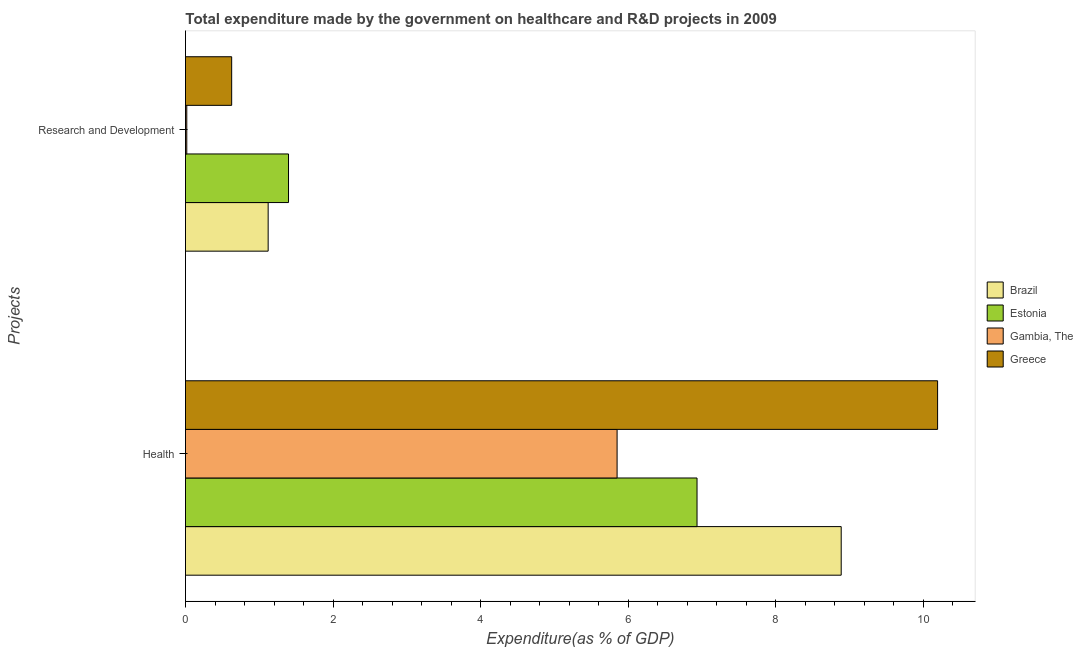How many different coloured bars are there?
Offer a terse response. 4. Are the number of bars per tick equal to the number of legend labels?
Give a very brief answer. Yes. Are the number of bars on each tick of the Y-axis equal?
Your answer should be compact. Yes. How many bars are there on the 2nd tick from the top?
Give a very brief answer. 4. How many bars are there on the 2nd tick from the bottom?
Your answer should be very brief. 4. What is the label of the 2nd group of bars from the top?
Your answer should be compact. Health. What is the expenditure in r&d in Gambia, The?
Provide a short and direct response. 0.02. Across all countries, what is the maximum expenditure in r&d?
Give a very brief answer. 1.4. Across all countries, what is the minimum expenditure in healthcare?
Provide a succinct answer. 5.85. In which country was the expenditure in r&d maximum?
Provide a short and direct response. Estonia. In which country was the expenditure in r&d minimum?
Make the answer very short. Gambia, The. What is the total expenditure in r&d in the graph?
Your answer should be very brief. 3.16. What is the difference between the expenditure in healthcare in Gambia, The and that in Greece?
Keep it short and to the point. -4.34. What is the difference between the expenditure in r&d in Brazil and the expenditure in healthcare in Gambia, The?
Offer a terse response. -4.73. What is the average expenditure in healthcare per country?
Make the answer very short. 7.97. What is the difference between the expenditure in healthcare and expenditure in r&d in Estonia?
Your response must be concise. 5.54. What is the ratio of the expenditure in r&d in Greece to that in Gambia, The?
Offer a terse response. 35.8. What does the 2nd bar from the top in Research and Development represents?
Make the answer very short. Gambia, The. How many bars are there?
Offer a terse response. 8. Are the values on the major ticks of X-axis written in scientific E-notation?
Provide a short and direct response. No. Does the graph contain any zero values?
Ensure brevity in your answer.  No. Does the graph contain grids?
Make the answer very short. No. How are the legend labels stacked?
Your answer should be very brief. Vertical. What is the title of the graph?
Give a very brief answer. Total expenditure made by the government on healthcare and R&D projects in 2009. Does "Venezuela" appear as one of the legend labels in the graph?
Your answer should be very brief. No. What is the label or title of the X-axis?
Your answer should be compact. Expenditure(as % of GDP). What is the label or title of the Y-axis?
Offer a very short reply. Projects. What is the Expenditure(as % of GDP) of Brazil in Health?
Your answer should be compact. 8.89. What is the Expenditure(as % of GDP) in Estonia in Health?
Your answer should be very brief. 6.93. What is the Expenditure(as % of GDP) in Gambia, The in Health?
Offer a very short reply. 5.85. What is the Expenditure(as % of GDP) in Greece in Health?
Offer a terse response. 10.19. What is the Expenditure(as % of GDP) in Brazil in Research and Development?
Offer a terse response. 1.12. What is the Expenditure(as % of GDP) in Estonia in Research and Development?
Make the answer very short. 1.4. What is the Expenditure(as % of GDP) in Gambia, The in Research and Development?
Your answer should be compact. 0.02. What is the Expenditure(as % of GDP) of Greece in Research and Development?
Offer a terse response. 0.63. Across all Projects, what is the maximum Expenditure(as % of GDP) in Brazil?
Provide a short and direct response. 8.89. Across all Projects, what is the maximum Expenditure(as % of GDP) in Estonia?
Provide a short and direct response. 6.93. Across all Projects, what is the maximum Expenditure(as % of GDP) of Gambia, The?
Provide a short and direct response. 5.85. Across all Projects, what is the maximum Expenditure(as % of GDP) of Greece?
Offer a terse response. 10.19. Across all Projects, what is the minimum Expenditure(as % of GDP) of Brazil?
Provide a short and direct response. 1.12. Across all Projects, what is the minimum Expenditure(as % of GDP) of Estonia?
Provide a short and direct response. 1.4. Across all Projects, what is the minimum Expenditure(as % of GDP) in Gambia, The?
Provide a succinct answer. 0.02. Across all Projects, what is the minimum Expenditure(as % of GDP) of Greece?
Keep it short and to the point. 0.63. What is the total Expenditure(as % of GDP) of Brazil in the graph?
Your response must be concise. 10.01. What is the total Expenditure(as % of GDP) of Estonia in the graph?
Ensure brevity in your answer.  8.33. What is the total Expenditure(as % of GDP) of Gambia, The in the graph?
Keep it short and to the point. 5.87. What is the total Expenditure(as % of GDP) in Greece in the graph?
Ensure brevity in your answer.  10.82. What is the difference between the Expenditure(as % of GDP) in Brazil in Health and that in Research and Development?
Make the answer very short. 7.77. What is the difference between the Expenditure(as % of GDP) of Estonia in Health and that in Research and Development?
Provide a succinct answer. 5.54. What is the difference between the Expenditure(as % of GDP) of Gambia, The in Health and that in Research and Development?
Give a very brief answer. 5.83. What is the difference between the Expenditure(as % of GDP) of Greece in Health and that in Research and Development?
Ensure brevity in your answer.  9.57. What is the difference between the Expenditure(as % of GDP) of Brazil in Health and the Expenditure(as % of GDP) of Estonia in Research and Development?
Offer a very short reply. 7.49. What is the difference between the Expenditure(as % of GDP) of Brazil in Health and the Expenditure(as % of GDP) of Gambia, The in Research and Development?
Your answer should be very brief. 8.87. What is the difference between the Expenditure(as % of GDP) in Brazil in Health and the Expenditure(as % of GDP) in Greece in Research and Development?
Give a very brief answer. 8.26. What is the difference between the Expenditure(as % of GDP) of Estonia in Health and the Expenditure(as % of GDP) of Gambia, The in Research and Development?
Make the answer very short. 6.91. What is the difference between the Expenditure(as % of GDP) in Estonia in Health and the Expenditure(as % of GDP) in Greece in Research and Development?
Make the answer very short. 6.31. What is the difference between the Expenditure(as % of GDP) of Gambia, The in Health and the Expenditure(as % of GDP) of Greece in Research and Development?
Give a very brief answer. 5.22. What is the average Expenditure(as % of GDP) of Brazil per Projects?
Keep it short and to the point. 5. What is the average Expenditure(as % of GDP) in Estonia per Projects?
Provide a succinct answer. 4.16. What is the average Expenditure(as % of GDP) in Gambia, The per Projects?
Ensure brevity in your answer.  2.93. What is the average Expenditure(as % of GDP) of Greece per Projects?
Offer a terse response. 5.41. What is the difference between the Expenditure(as % of GDP) of Brazil and Expenditure(as % of GDP) of Estonia in Health?
Provide a succinct answer. 1.95. What is the difference between the Expenditure(as % of GDP) in Brazil and Expenditure(as % of GDP) in Gambia, The in Health?
Give a very brief answer. 3.04. What is the difference between the Expenditure(as % of GDP) in Brazil and Expenditure(as % of GDP) in Greece in Health?
Your response must be concise. -1.31. What is the difference between the Expenditure(as % of GDP) in Estonia and Expenditure(as % of GDP) in Gambia, The in Health?
Provide a short and direct response. 1.08. What is the difference between the Expenditure(as % of GDP) of Estonia and Expenditure(as % of GDP) of Greece in Health?
Ensure brevity in your answer.  -3.26. What is the difference between the Expenditure(as % of GDP) of Gambia, The and Expenditure(as % of GDP) of Greece in Health?
Make the answer very short. -4.34. What is the difference between the Expenditure(as % of GDP) of Brazil and Expenditure(as % of GDP) of Estonia in Research and Development?
Give a very brief answer. -0.28. What is the difference between the Expenditure(as % of GDP) of Brazil and Expenditure(as % of GDP) of Gambia, The in Research and Development?
Your response must be concise. 1.1. What is the difference between the Expenditure(as % of GDP) of Brazil and Expenditure(as % of GDP) of Greece in Research and Development?
Your response must be concise. 0.49. What is the difference between the Expenditure(as % of GDP) in Estonia and Expenditure(as % of GDP) in Gambia, The in Research and Development?
Make the answer very short. 1.38. What is the difference between the Expenditure(as % of GDP) of Estonia and Expenditure(as % of GDP) of Greece in Research and Development?
Give a very brief answer. 0.77. What is the difference between the Expenditure(as % of GDP) in Gambia, The and Expenditure(as % of GDP) in Greece in Research and Development?
Your response must be concise. -0.61. What is the ratio of the Expenditure(as % of GDP) of Brazil in Health to that in Research and Development?
Ensure brevity in your answer.  7.93. What is the ratio of the Expenditure(as % of GDP) of Estonia in Health to that in Research and Development?
Your answer should be very brief. 4.97. What is the ratio of the Expenditure(as % of GDP) in Gambia, The in Health to that in Research and Development?
Offer a terse response. 334.62. What is the ratio of the Expenditure(as % of GDP) in Greece in Health to that in Research and Development?
Keep it short and to the point. 16.29. What is the difference between the highest and the second highest Expenditure(as % of GDP) of Brazil?
Your answer should be very brief. 7.77. What is the difference between the highest and the second highest Expenditure(as % of GDP) in Estonia?
Provide a short and direct response. 5.54. What is the difference between the highest and the second highest Expenditure(as % of GDP) in Gambia, The?
Provide a short and direct response. 5.83. What is the difference between the highest and the second highest Expenditure(as % of GDP) in Greece?
Offer a terse response. 9.57. What is the difference between the highest and the lowest Expenditure(as % of GDP) of Brazil?
Your answer should be very brief. 7.77. What is the difference between the highest and the lowest Expenditure(as % of GDP) in Estonia?
Offer a terse response. 5.54. What is the difference between the highest and the lowest Expenditure(as % of GDP) in Gambia, The?
Provide a succinct answer. 5.83. What is the difference between the highest and the lowest Expenditure(as % of GDP) in Greece?
Your answer should be very brief. 9.57. 